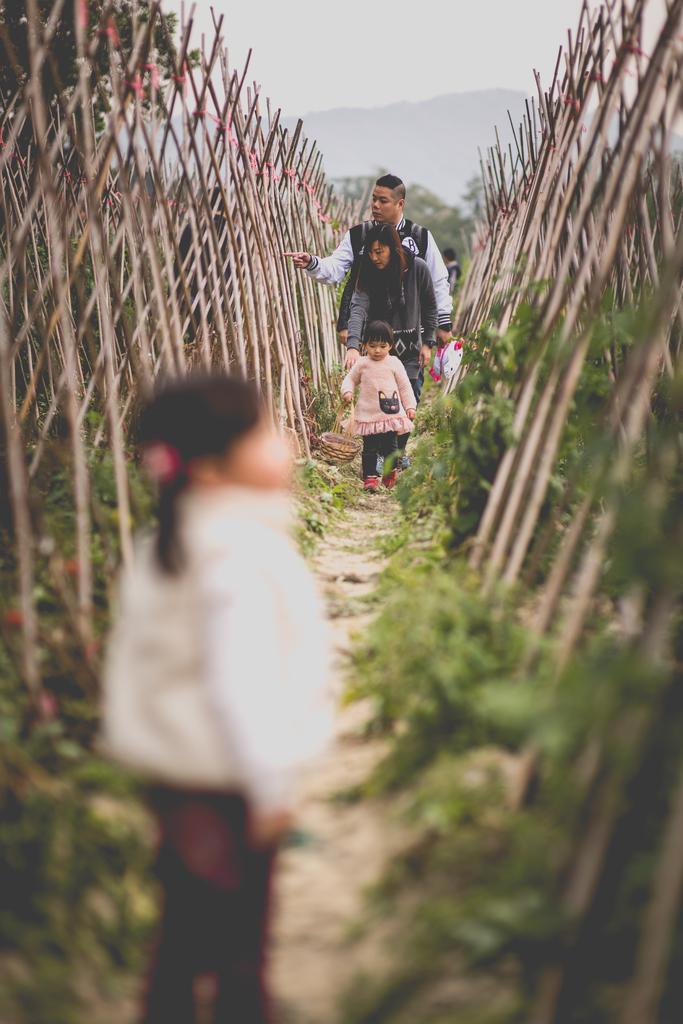Describe this image in one or two sentences. In the foreground of this picture, there is a girl standing on the path, where we can see fencing with wood and plants on the either side to the path. In the background, there are persons walking on the path, mountains and the sky. 